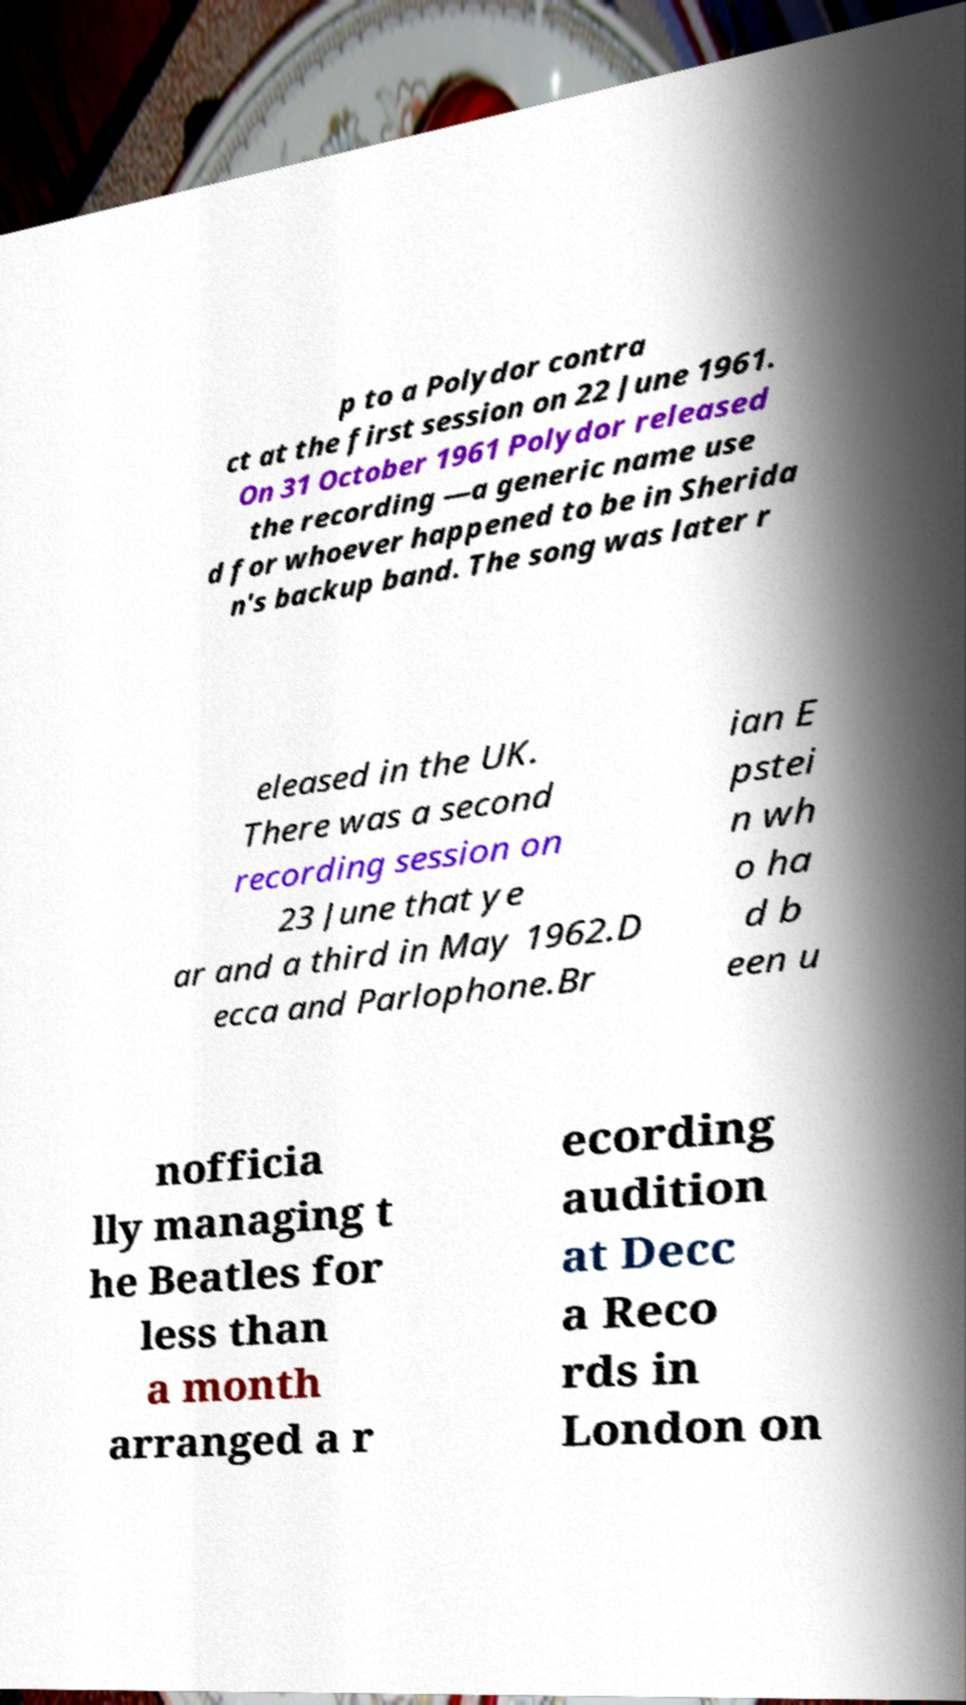For documentation purposes, I need the text within this image transcribed. Could you provide that? p to a Polydor contra ct at the first session on 22 June 1961. On 31 October 1961 Polydor released the recording —a generic name use d for whoever happened to be in Sherida n's backup band. The song was later r eleased in the UK. There was a second recording session on 23 June that ye ar and a third in May 1962.D ecca and Parlophone.Br ian E pstei n wh o ha d b een u nofficia lly managing t he Beatles for less than a month arranged a r ecording audition at Decc a Reco rds in London on 